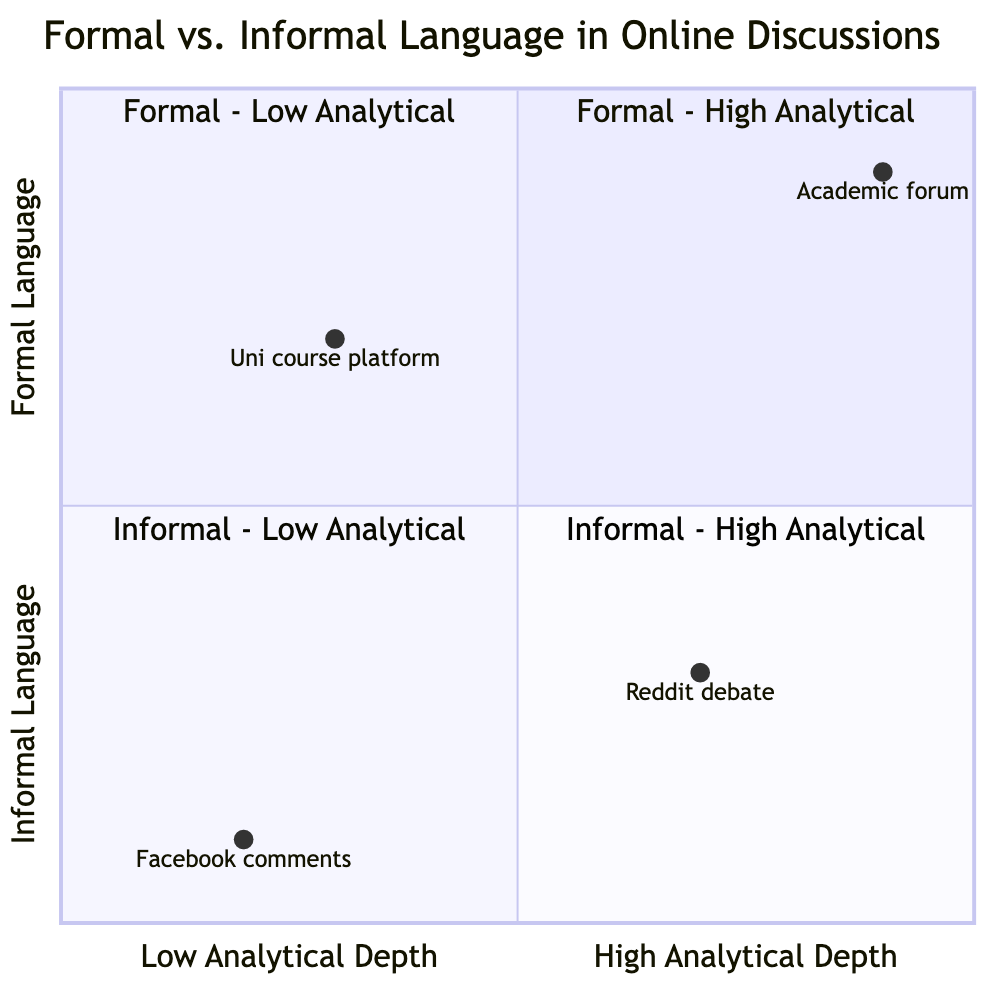What is the highest analytical depth formal language category in this diagram? The highest analytical depth formal language category is "Formal Language - High Analytical Depth", which is identified in the top-left quadrant of the chart.
Answer: Formal Language - High Analytical Depth Which quadrant contains comments from a government policy on an official news website? Comments on a government policy in an official news website fall into the "Formal Language - Low Analytical Depth" category, which is located in the upper-right quadrant.
Answer: Formal Language - Low Analytical Depth How many examples are associated with informal language in low analytical depth? There are two examples mentioned in the "Informal Language - Low Analytical Depth" quadrant, which are shown in the bottom-right section of the chart.
Answer: 2 Which example is found in the quadrant of high analytical depth informal language? The quadrant labeled "Informal Language - High Analytical Depth" includes the "Debates in Reddit's subreddit like r/ChangeMyView" example, located in the lower-left quadrant.
Answer: Debates in Reddit's subreddit like r/ChangeMyView What type of language structure is used in "Responses in a university online course platform"? The structure used in "Responses in a university online course platform" falls under the "Formal Language - Low Analytical Depth", indicating it has a simpler sentence structure while maintaining a formal tone.
Answer: Simpler sentence structures Which quadrant has the highest examples with an emotional appeal rather than logic? The quadrant "Informal Language - Low Analytical Depth" contains the highest examples that focus on emotional appeal rather than logic, found in the lower-right section of the diagram.
Answer: Informal Language - Low Analytical Depth What is the overall trend for language type as the analytical depth increases? The trend shows that as analytical depth increases from low to high, the language type transitions from informal to formal. This is visually represented by the movement from the bottom-right to the top-left quadrant of the chart.
Answer: Transition from informal to formal Which quadrant represents the combination of accessible language and complex idea presentation? The quadrant that represents accessible language combined with the presentation of complex ideas is "Informal Language - High Analytical Depth", located in the lower-left quadrant of the diagram.
Answer: Informal Language - High Analytical Depth 